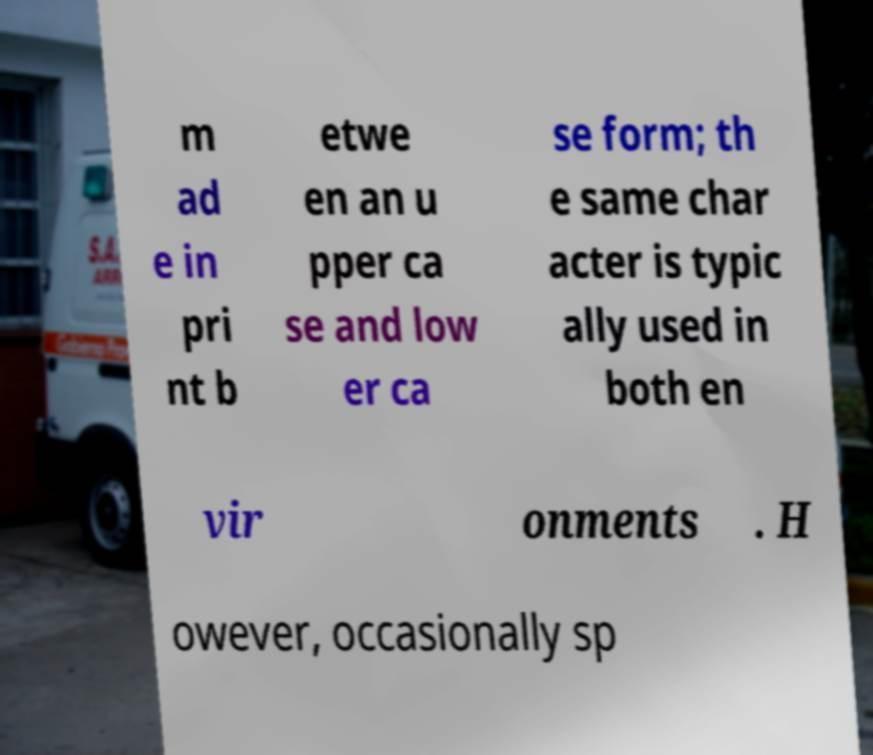Can you accurately transcribe the text from the provided image for me? m ad e in pri nt b etwe en an u pper ca se and low er ca se form; th e same char acter is typic ally used in both en vir onments . H owever, occasionally sp 